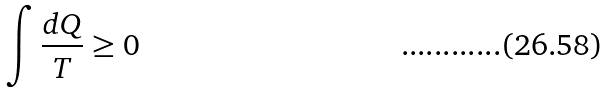Convert formula to latex. <formula><loc_0><loc_0><loc_500><loc_500>\int \frac { d Q } { T } \geq 0</formula> 